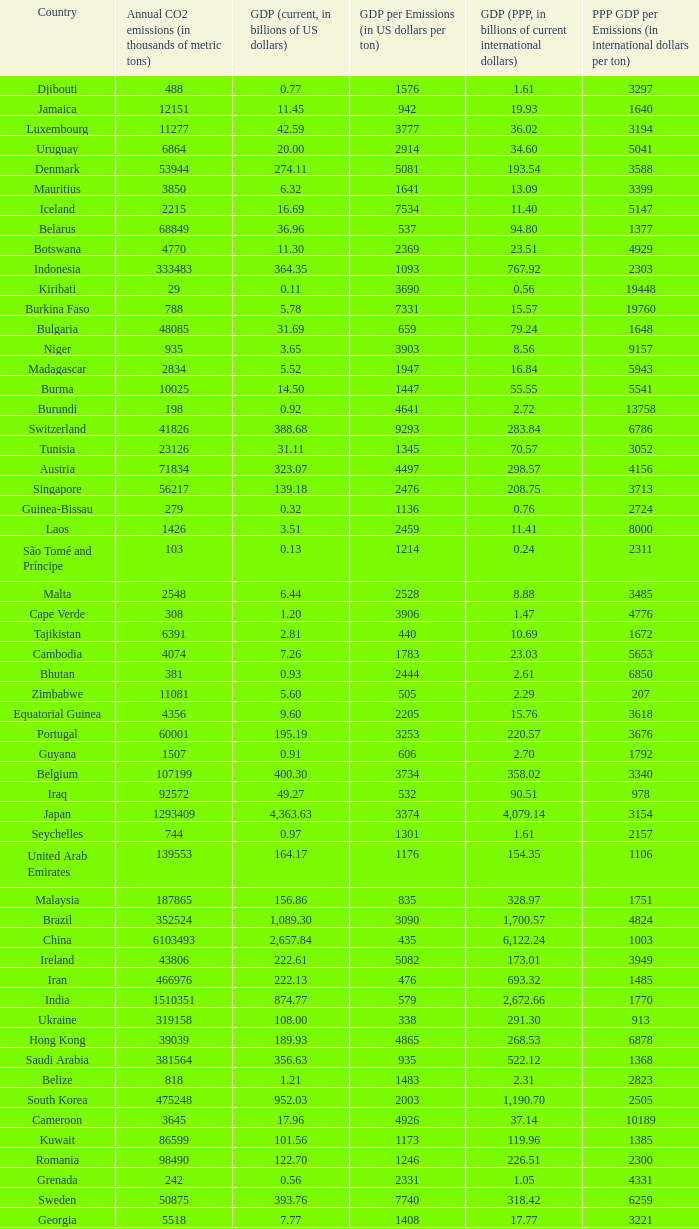When the gdp (ppp, in billions of current international dollars) is 7.93, what is the maximum ppp gdp per emissions (in international dollars per ton)? 9960.0. 